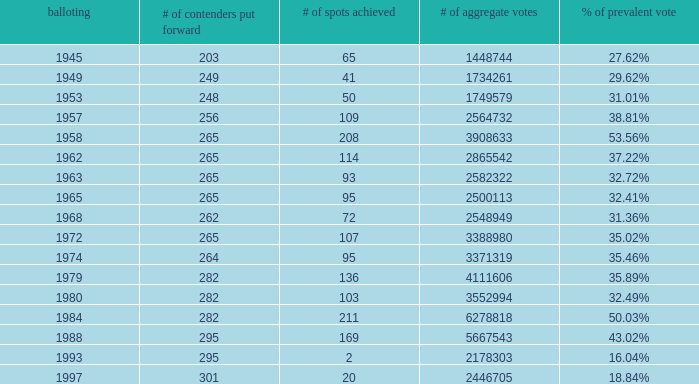What was the lowest # of total votes? 1448744.0. 